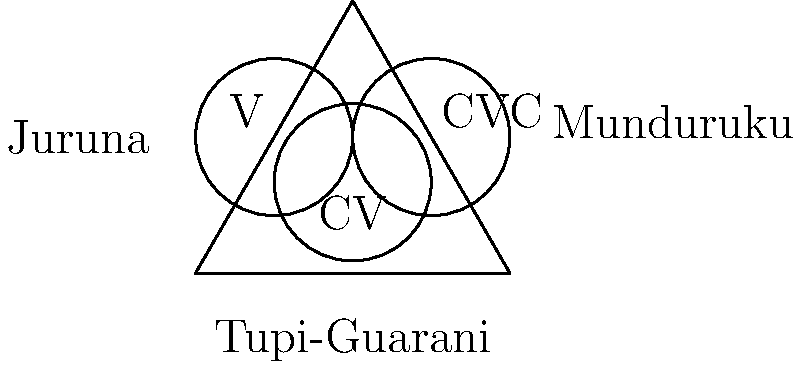Based on the Venn diagram representing syllable structures in three Tupi language branches, which syllable structure is common to all three branches? To answer this question, we need to analyze the Venn diagram carefully:

1. The diagram shows three intersecting circles, each representing a different Tupi language branch: Tupi-Guarani, Munduruku, and Juruna.

2. Each circle contains syllable structures:
   - The leftmost circle (Juruna) contains V (vowel)
   - The rightmost circle (Munduruku) contains CVC (consonant-vowel-consonant)
   - The bottom circle (Tupi-Guarani) contains CV (consonant-vowel)

3. The intersection of all three circles represents the syllable structure common to all three branches.

4. We can see that the CV structure is located at the center of the diagram, where all three circles intersect.

5. This indicates that the CV (consonant-vowel) syllable structure is common to Tupi-Guarani, Munduruku, and Juruna branches.

Therefore, the syllable structure common to all three Tupi language branches represented in the diagram is CV (consonant-vowel).
Answer: CV (consonant-vowel) 